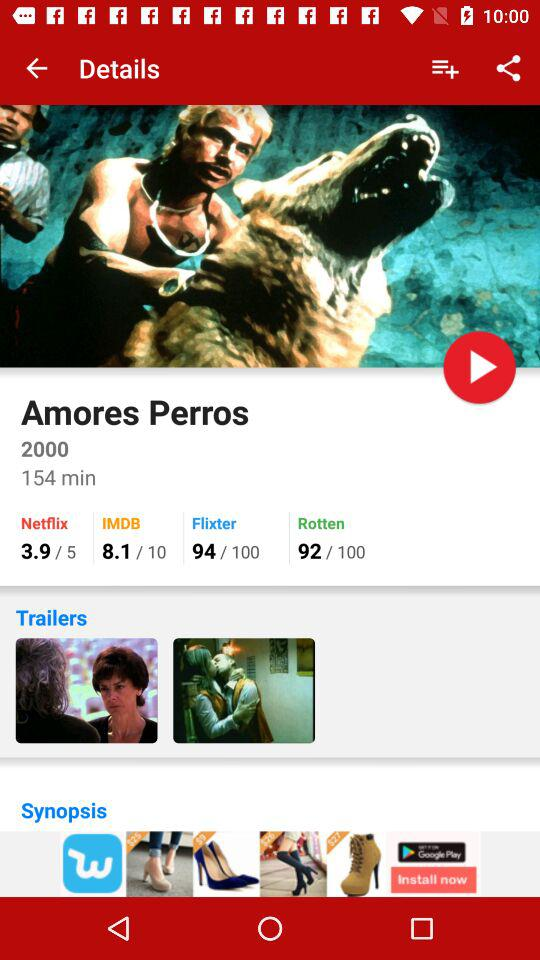What is the time duration of Amores Perros? The time duration is 154 minutes. 